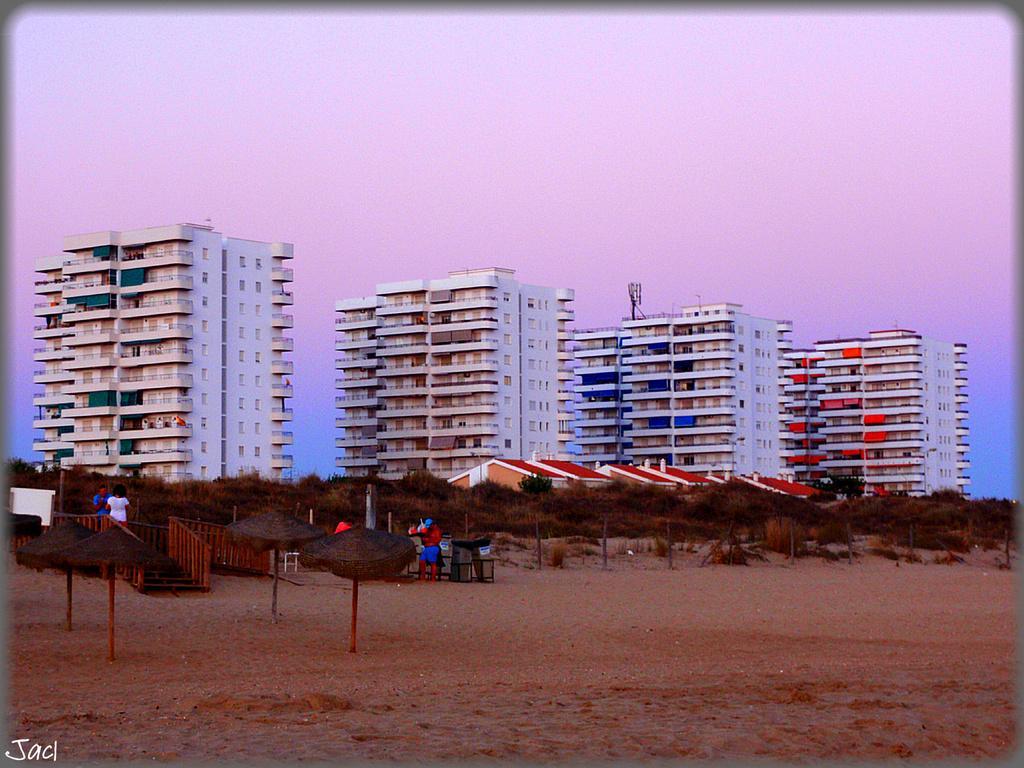Please provide a concise description of this image. In this image there are tall buildings one beside the other. At the bottom there is sand on which there are two umbrellas. In between the umbrellas there is a wooden floor on which there are two persons. In the middle there is a person. Beside him there are stools. There is a fence around the buildings. Beside the fence there are trees and houses. At the top there is the sky. 